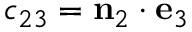<formula> <loc_0><loc_0><loc_500><loc_500>c _ { 2 3 } = n _ { 2 } \cdot e _ { 3 }</formula> 